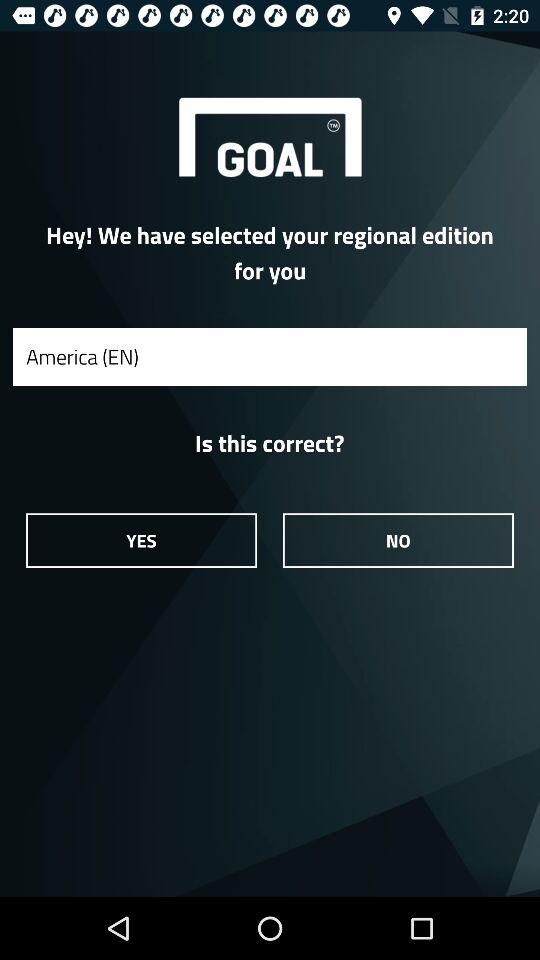Which is the selected regional edition? The selected regional edition is "America (EN)". 